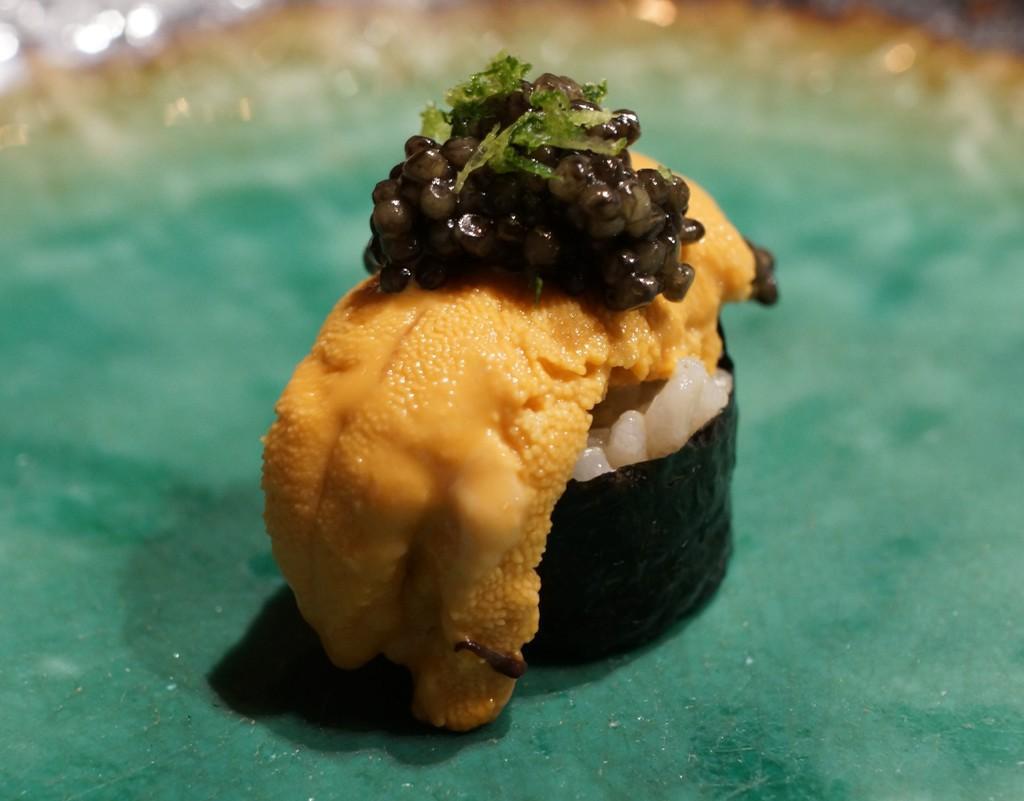In one or two sentences, can you explain what this image depicts? In the middle of the image there is sushi places on the green surface. 